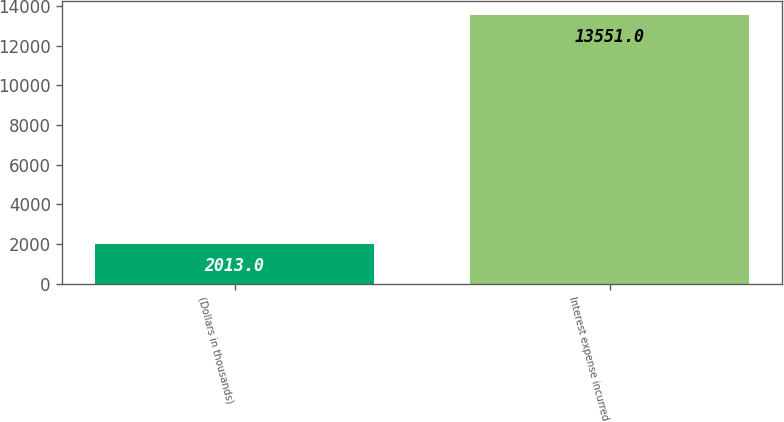Convert chart to OTSL. <chart><loc_0><loc_0><loc_500><loc_500><bar_chart><fcel>(Dollars in thousands)<fcel>Interest expense incurred<nl><fcel>2013<fcel>13551<nl></chart> 